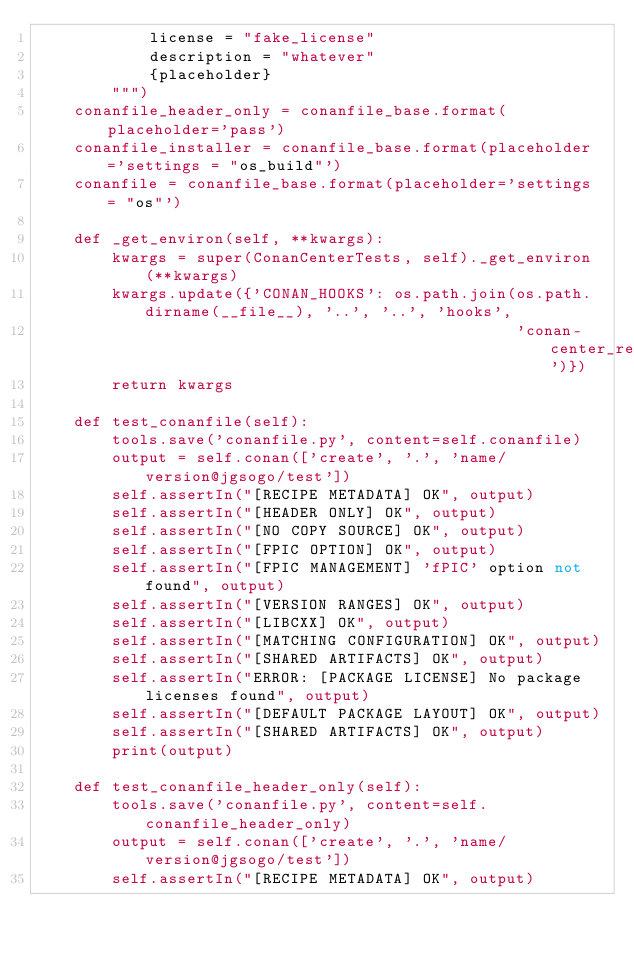Convert code to text. <code><loc_0><loc_0><loc_500><loc_500><_Python_>            license = "fake_license"
            description = "whatever"
            {placeholder}
        """)
    conanfile_header_only = conanfile_base.format(placeholder='pass')
    conanfile_installer = conanfile_base.format(placeholder='settings = "os_build"')
    conanfile = conanfile_base.format(placeholder='settings = "os"')

    def _get_environ(self, **kwargs):
        kwargs = super(ConanCenterTests, self)._get_environ(**kwargs)
        kwargs.update({'CONAN_HOOKS': os.path.join(os.path.dirname(__file__), '..', '..', 'hooks',
                                                   'conan-center_reviewer')})
        return kwargs

    def test_conanfile(self):
        tools.save('conanfile.py', content=self.conanfile)
        output = self.conan(['create', '.', 'name/version@jgsogo/test'])
        self.assertIn("[RECIPE METADATA] OK", output)
        self.assertIn("[HEADER ONLY] OK", output)
        self.assertIn("[NO COPY SOURCE] OK", output)
        self.assertIn("[FPIC OPTION] OK", output)
        self.assertIn("[FPIC MANAGEMENT] 'fPIC' option not found", output)
        self.assertIn("[VERSION RANGES] OK", output)
        self.assertIn("[LIBCXX] OK", output)
        self.assertIn("[MATCHING CONFIGURATION] OK", output)
        self.assertIn("[SHARED ARTIFACTS] OK", output)
        self.assertIn("ERROR: [PACKAGE LICENSE] No package licenses found", output)
        self.assertIn("[DEFAULT PACKAGE LAYOUT] OK", output)
        self.assertIn("[SHARED ARTIFACTS] OK", output)
        print(output)

    def test_conanfile_header_only(self):
        tools.save('conanfile.py', content=self.conanfile_header_only)
        output = self.conan(['create', '.', 'name/version@jgsogo/test'])
        self.assertIn("[RECIPE METADATA] OK", output)</code> 